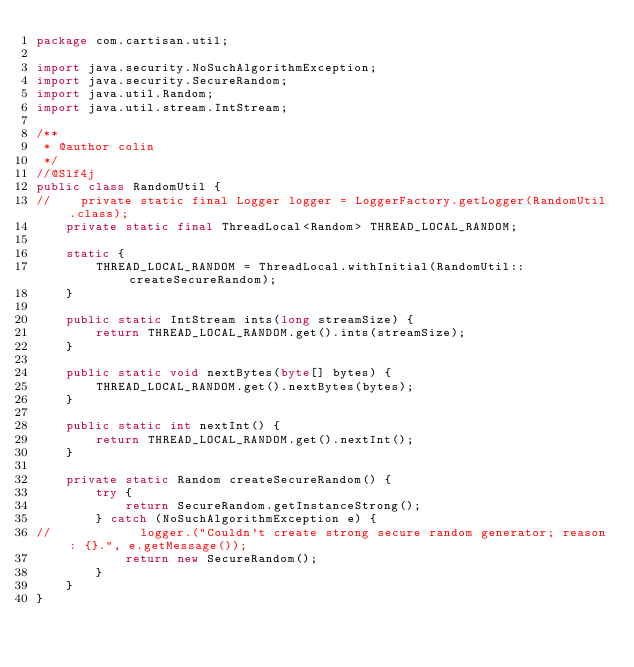<code> <loc_0><loc_0><loc_500><loc_500><_Java_>package com.cartisan.util;

import java.security.NoSuchAlgorithmException;
import java.security.SecureRandom;
import java.util.Random;
import java.util.stream.IntStream;

/**
 * @author colin
 */
//@Slf4j
public class RandomUtil {
//    private static final Logger logger = LoggerFactory.getLogger(RandomUtil.class);
    private static final ThreadLocal<Random> THREAD_LOCAL_RANDOM;

    static {
        THREAD_LOCAL_RANDOM = ThreadLocal.withInitial(RandomUtil::createSecureRandom);
    }

    public static IntStream ints(long streamSize) {
        return THREAD_LOCAL_RANDOM.get().ints(streamSize);
    }

    public static void nextBytes(byte[] bytes) {
        THREAD_LOCAL_RANDOM.get().nextBytes(bytes);
    }

    public static int nextInt() {
        return THREAD_LOCAL_RANDOM.get().nextInt();
    }

    private static Random createSecureRandom() {
        try {
            return SecureRandom.getInstanceStrong();
        } catch (NoSuchAlgorithmException e) {
//            logger.("Couldn't create strong secure random generator; reason: {}.", e.getMessage());
            return new SecureRandom();
        }
    }
}
</code> 